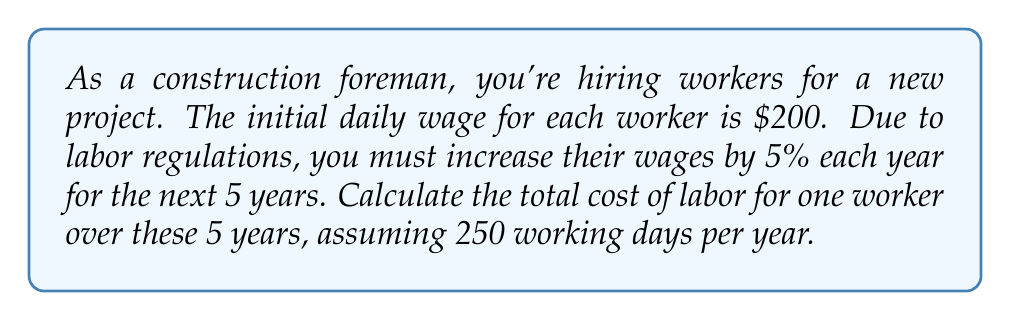Provide a solution to this math problem. Let's approach this step-by-step:

1) First, we need to calculate the daily wage for each year:
   Year 1: $200
   Year 2: $200 * 1.05 = $210
   Year 3: $210 * 1.05 = $220.50
   Year 4: $220.50 * 1.05 = $231.53 (rounded to cents)
   Year 5: $231.53 * 1.05 = $243.11 (rounded to cents)

2) Now, we have an arithmetic sequence of annual wages:
   $$a_n = 200 * (1.05)^{n-1}$$
   where $n$ is the year number.

3) To calculate the total cost, we need to sum these daily wages over 250 days for each year:
   Year 1: $200 * 250 = $50,000
   Year 2: $210 * 250 = $52,500
   Year 3: $220.50 * 250 = $55,125
   Year 4: $231.53 * 250 = $57,882.50
   Year 5: $243.11 * 250 = $60,777.50

4) The total cost is the sum of these annual costs:
   $$\text{Total Cost} = \sum_{n=1}^{5} 250 * 200 * (1.05)^{n-1}$$

5) Calculating this sum:
   $50,000 + $52,500 + $55,125 + $57,882.50 + $60,777.50 = $276,285

Therefore, the total cost of labor for one worker over 5 years is $276,285.
Answer: $276,285 